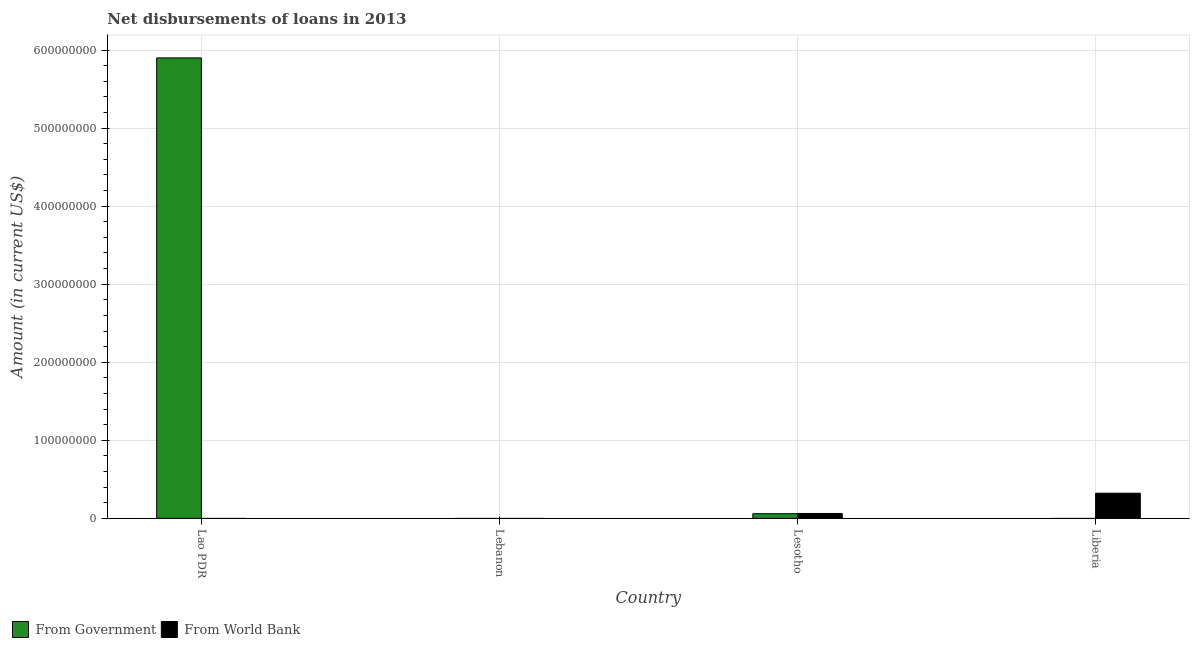How many different coloured bars are there?
Provide a short and direct response. 2. How many bars are there on the 3rd tick from the right?
Give a very brief answer. 0. What is the label of the 4th group of bars from the left?
Keep it short and to the point. Liberia. What is the net disbursements of loan from world bank in Lesotho?
Make the answer very short. 6.30e+06. Across all countries, what is the maximum net disbursements of loan from world bank?
Ensure brevity in your answer.  3.23e+07. In which country was the net disbursements of loan from government maximum?
Ensure brevity in your answer.  Lao PDR. What is the total net disbursements of loan from government in the graph?
Your response must be concise. 5.96e+08. What is the difference between the net disbursements of loan from government in Lao PDR and that in Lesotho?
Make the answer very short. 5.84e+08. What is the difference between the net disbursements of loan from world bank in Lesotho and the net disbursements of loan from government in Lebanon?
Your answer should be compact. 6.30e+06. What is the average net disbursements of loan from government per country?
Give a very brief answer. 1.49e+08. What is the difference between the net disbursements of loan from world bank and net disbursements of loan from government in Lesotho?
Your answer should be compact. 2.77e+05. What is the difference between the highest and the lowest net disbursements of loan from government?
Make the answer very short. 5.90e+08. How many countries are there in the graph?
Ensure brevity in your answer.  4. Are the values on the major ticks of Y-axis written in scientific E-notation?
Provide a short and direct response. No. Does the graph contain any zero values?
Your answer should be compact. Yes. Does the graph contain grids?
Provide a succinct answer. Yes. Where does the legend appear in the graph?
Offer a very short reply. Bottom left. How many legend labels are there?
Offer a very short reply. 2. How are the legend labels stacked?
Provide a short and direct response. Horizontal. What is the title of the graph?
Keep it short and to the point. Net disbursements of loans in 2013. What is the label or title of the X-axis?
Keep it short and to the point. Country. What is the label or title of the Y-axis?
Your answer should be compact. Amount (in current US$). What is the Amount (in current US$) in From Government in Lao PDR?
Give a very brief answer. 5.90e+08. What is the Amount (in current US$) of From World Bank in Lao PDR?
Keep it short and to the point. 0. What is the Amount (in current US$) of From World Bank in Lebanon?
Your answer should be very brief. 0. What is the Amount (in current US$) in From Government in Lesotho?
Keep it short and to the point. 6.02e+06. What is the Amount (in current US$) of From World Bank in Lesotho?
Provide a succinct answer. 6.30e+06. What is the Amount (in current US$) in From Government in Liberia?
Keep it short and to the point. 0. What is the Amount (in current US$) of From World Bank in Liberia?
Provide a succinct answer. 3.23e+07. Across all countries, what is the maximum Amount (in current US$) of From Government?
Provide a succinct answer. 5.90e+08. Across all countries, what is the maximum Amount (in current US$) in From World Bank?
Your answer should be compact. 3.23e+07. What is the total Amount (in current US$) in From Government in the graph?
Make the answer very short. 5.96e+08. What is the total Amount (in current US$) in From World Bank in the graph?
Provide a succinct answer. 3.86e+07. What is the difference between the Amount (in current US$) of From Government in Lao PDR and that in Lesotho?
Ensure brevity in your answer.  5.84e+08. What is the difference between the Amount (in current US$) of From World Bank in Lesotho and that in Liberia?
Keep it short and to the point. -2.60e+07. What is the difference between the Amount (in current US$) in From Government in Lao PDR and the Amount (in current US$) in From World Bank in Lesotho?
Your answer should be compact. 5.84e+08. What is the difference between the Amount (in current US$) in From Government in Lao PDR and the Amount (in current US$) in From World Bank in Liberia?
Your answer should be very brief. 5.58e+08. What is the difference between the Amount (in current US$) in From Government in Lesotho and the Amount (in current US$) in From World Bank in Liberia?
Your answer should be compact. -2.62e+07. What is the average Amount (in current US$) of From Government per country?
Provide a succinct answer. 1.49e+08. What is the average Amount (in current US$) in From World Bank per country?
Offer a very short reply. 9.64e+06. What is the difference between the Amount (in current US$) of From Government and Amount (in current US$) of From World Bank in Lesotho?
Offer a terse response. -2.77e+05. What is the ratio of the Amount (in current US$) of From Government in Lao PDR to that in Lesotho?
Your answer should be compact. 97.96. What is the ratio of the Amount (in current US$) in From World Bank in Lesotho to that in Liberia?
Provide a succinct answer. 0.2. What is the difference between the highest and the lowest Amount (in current US$) in From Government?
Offer a very short reply. 5.90e+08. What is the difference between the highest and the lowest Amount (in current US$) of From World Bank?
Provide a short and direct response. 3.23e+07. 